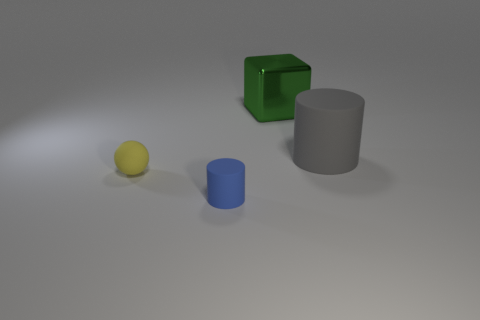Is there a blue object of the same shape as the gray thing?
Keep it short and to the point. Yes. Are there fewer large blue matte blocks than large matte objects?
Offer a very short reply. Yes. There is a matte cylinder that is on the left side of the green metallic object; is its size the same as the cylinder right of the green metal thing?
Make the answer very short. No. How many objects are either large brown rubber cubes or small yellow objects?
Provide a succinct answer. 1. There is a matte cylinder behind the tiny yellow ball; what size is it?
Ensure brevity in your answer.  Large. How many small yellow matte spheres are left of the large thing to the left of the cylinder behind the rubber ball?
Keep it short and to the point. 1. Is the large cylinder the same color as the ball?
Offer a terse response. No. How many things are right of the tiny blue cylinder and to the left of the gray thing?
Your response must be concise. 1. What is the shape of the rubber object in front of the tiny yellow rubber ball?
Give a very brief answer. Cylinder. Are there fewer cylinders in front of the large shiny object than objects that are behind the blue matte object?
Provide a succinct answer. Yes. 